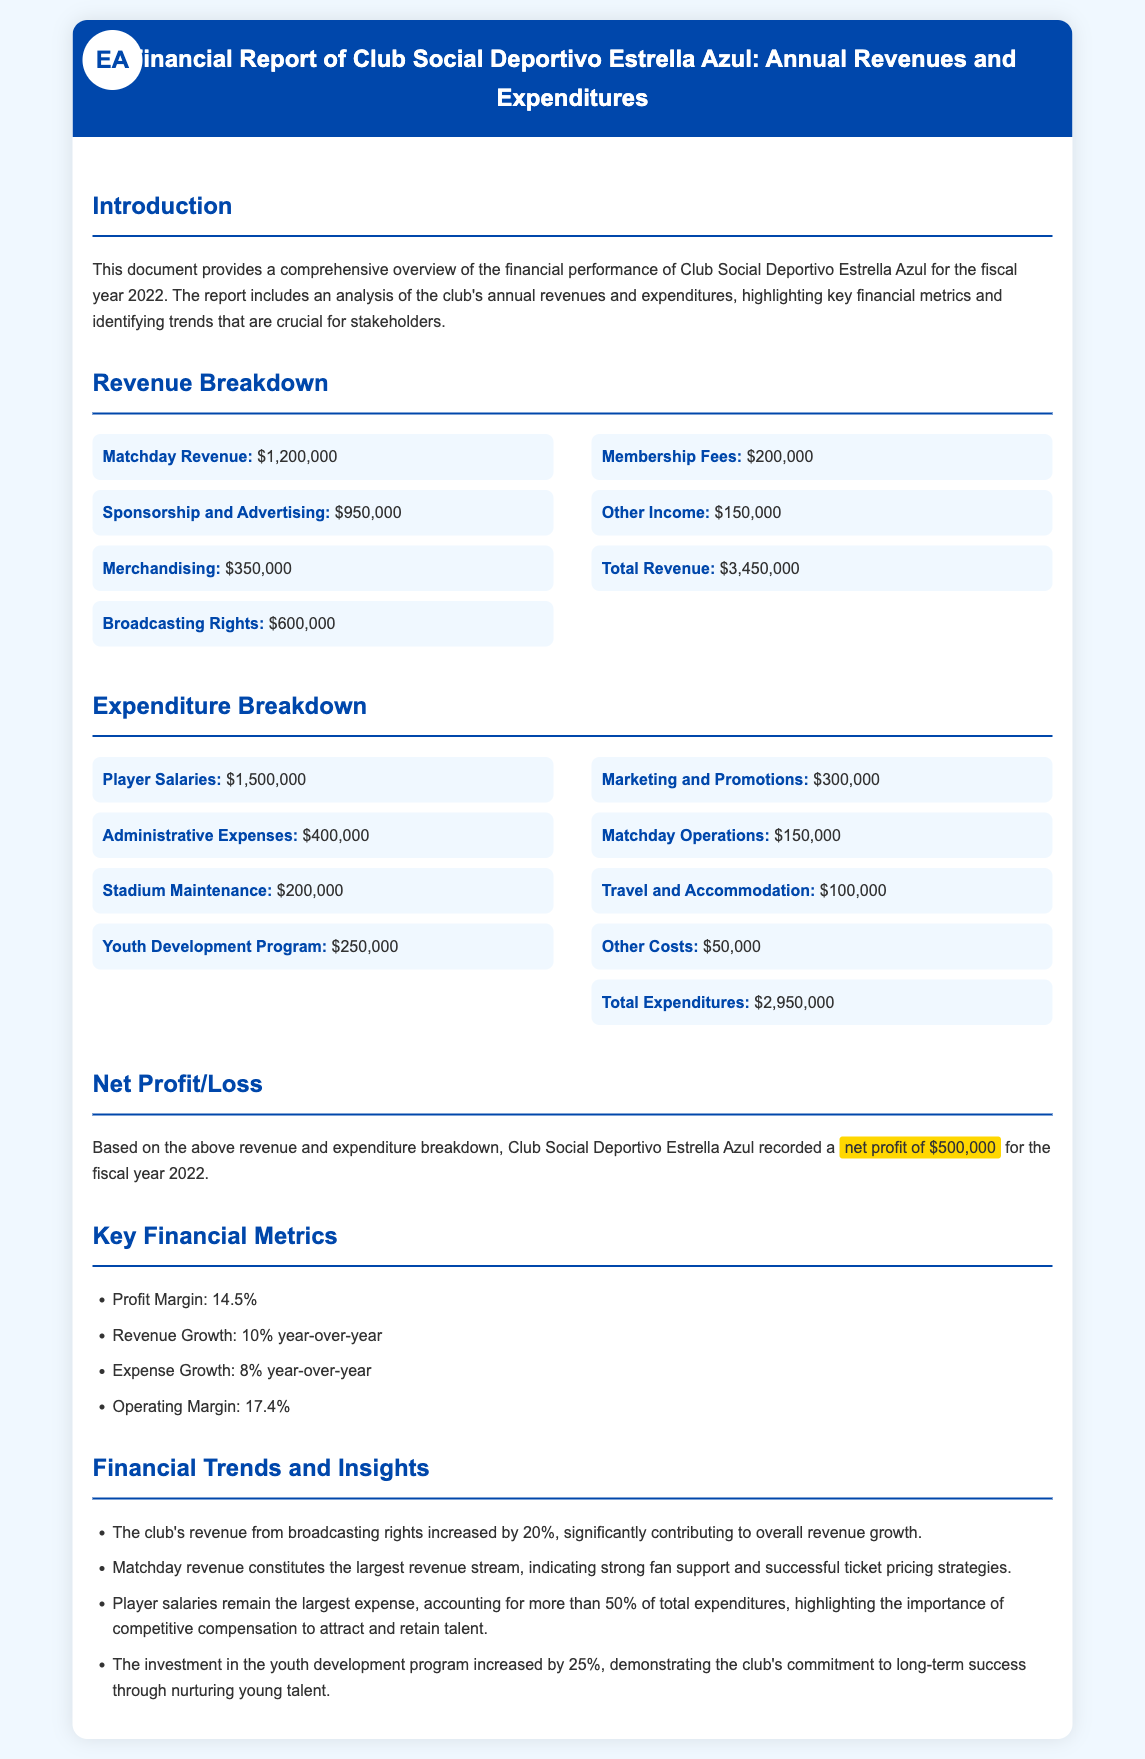What is the total revenue? The total revenue is the sum of all revenue sources, which are listed in the document.
Answer: $3,450,000 What is the total expenditure? The total expenditure is the sum of all expenditure categories provided in the document.
Answer: $2,950,000 What is the net profit for the fiscal year 2022? The net profit is found by subtracting total expenditures from total revenues in the report.
Answer: $500,000 What percentage of total expenditures do player salaries constitute? Player salaries amount to $1,500,000, which is more than 50% of total expenditures.
Answer: More than 50% Which revenue source has the highest value? Matchday revenue is the highest revenue source listed in the revenue breakdown.
Answer: Matchday Revenue What was the revenue growth rate? The document specifies that the revenue growth rate was 10% year-over-year.
Answer: 10% What is the profit margin? The profit margin is mentioned explicitly in the key financial metrics section of the document.
Answer: 14.5% By how much did the investment in the youth development program increase? The document states that investment in the youth development program increased by 25%.
Answer: 25% Which expenditure category has the lowest value? The lowest expenditure category listed is "Other Costs," with the specified amount.
Answer: $50,000 